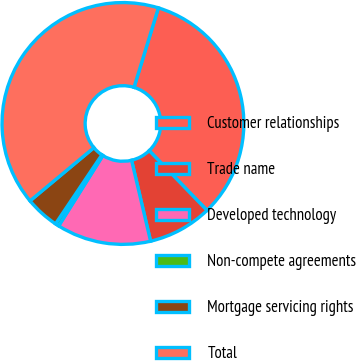Convert chart to OTSL. <chart><loc_0><loc_0><loc_500><loc_500><pie_chart><fcel>Customer relationships<fcel>Trade name<fcel>Developed technology<fcel>Non-compete agreements<fcel>Mortgage servicing rights<fcel>Total<nl><fcel>33.03%<fcel>8.56%<fcel>12.59%<fcel>0.5%<fcel>4.53%<fcel>40.79%<nl></chart> 